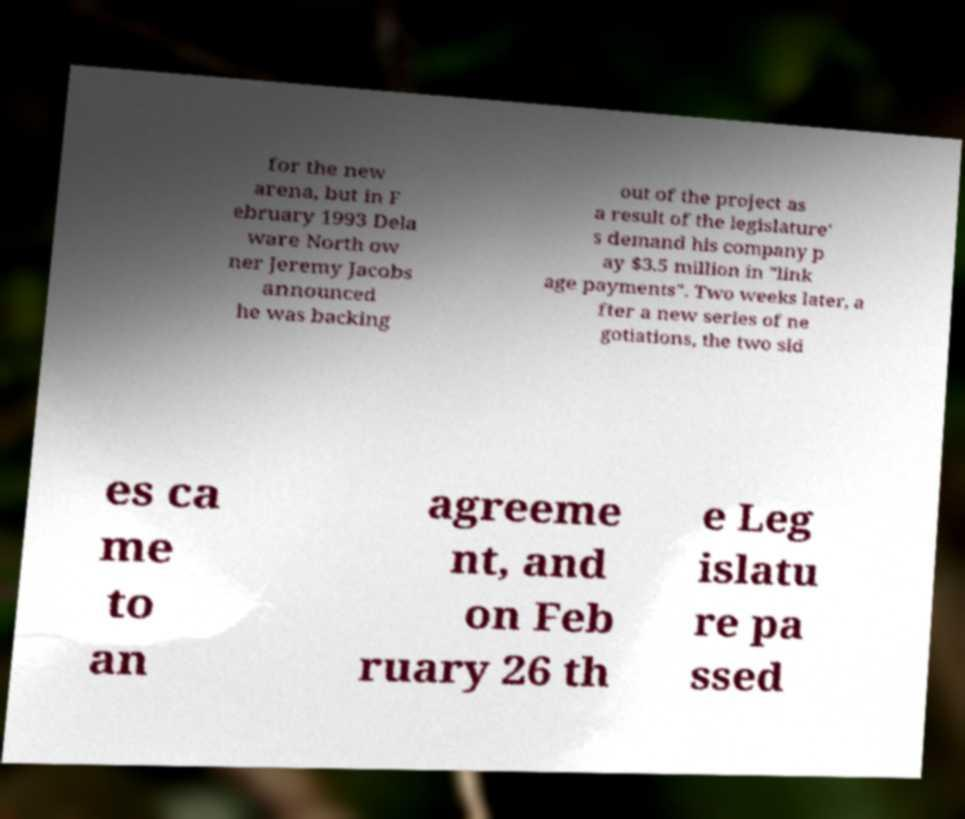For documentation purposes, I need the text within this image transcribed. Could you provide that? for the new arena, but in F ebruary 1993 Dela ware North ow ner Jeremy Jacobs announced he was backing out of the project as a result of the legislature' s demand his company p ay $3.5 million in "link age payments". Two weeks later, a fter a new series of ne gotiations, the two sid es ca me to an agreeme nt, and on Feb ruary 26 th e Leg islatu re pa ssed 